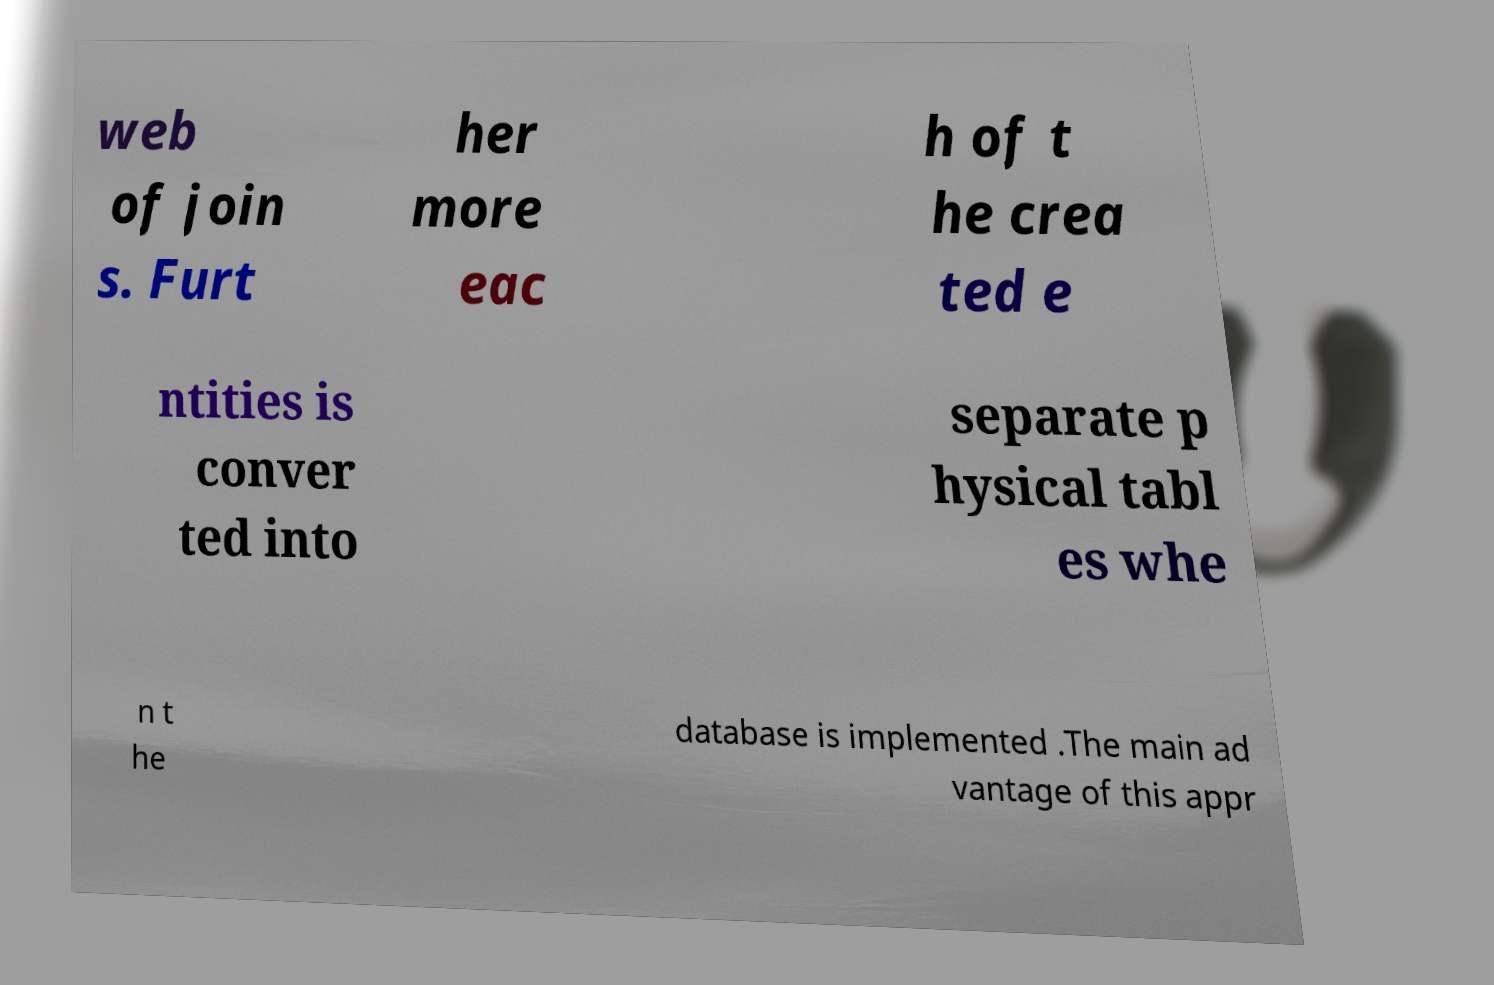Please read and relay the text visible in this image. What does it say? web of join s. Furt her more eac h of t he crea ted e ntities is conver ted into separate p hysical tabl es whe n t he database is implemented .The main ad vantage of this appr 